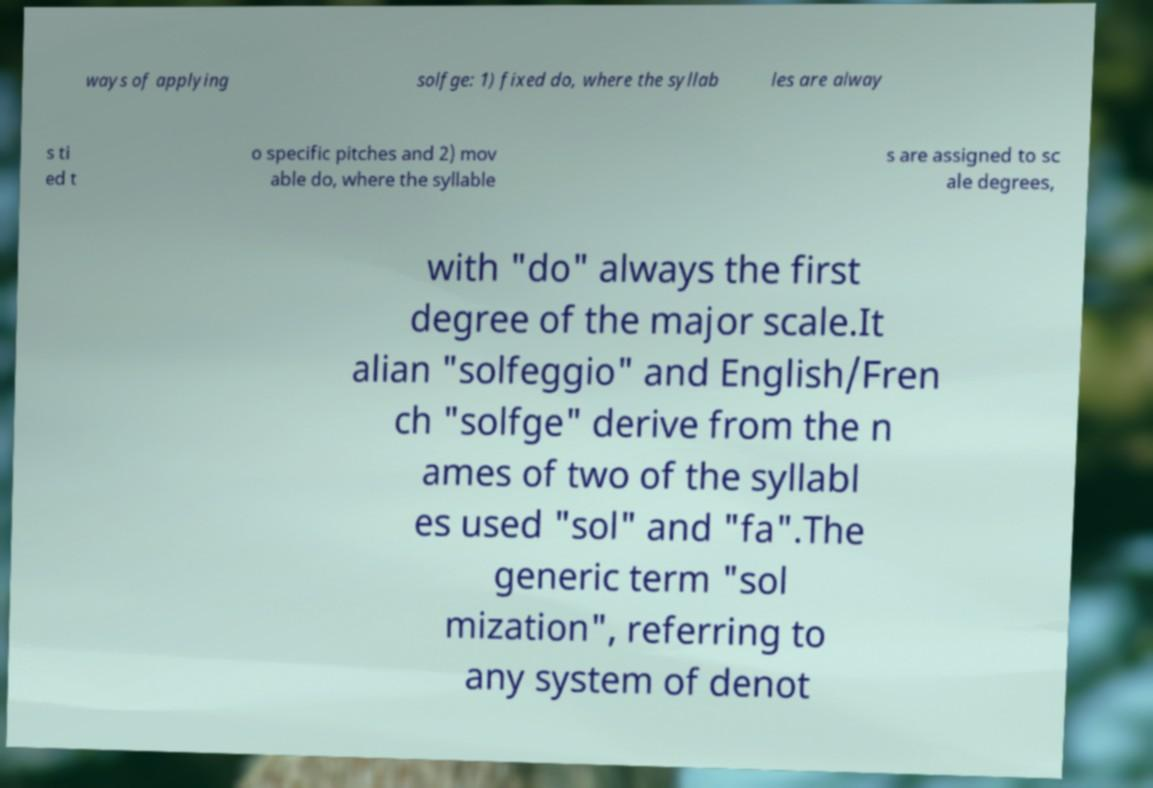Could you assist in decoding the text presented in this image and type it out clearly? ways of applying solfge: 1) fixed do, where the syllab les are alway s ti ed t o specific pitches and 2) mov able do, where the syllable s are assigned to sc ale degrees, with "do" always the first degree of the major scale.It alian "solfeggio" and English/Fren ch "solfge" derive from the n ames of two of the syllabl es used "sol" and "fa".The generic term "sol mization", referring to any system of denot 